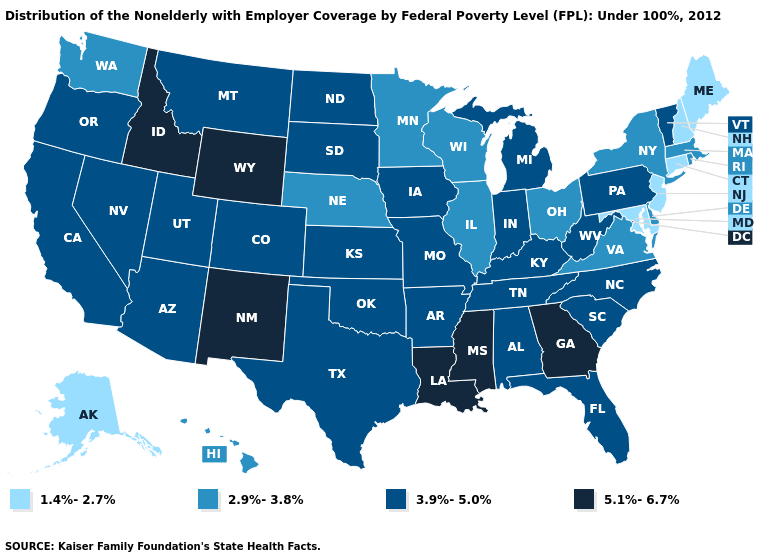What is the value of Kansas?
Concise answer only. 3.9%-5.0%. Does the first symbol in the legend represent the smallest category?
Concise answer only. Yes. Name the states that have a value in the range 3.9%-5.0%?
Be succinct. Alabama, Arizona, Arkansas, California, Colorado, Florida, Indiana, Iowa, Kansas, Kentucky, Michigan, Missouri, Montana, Nevada, North Carolina, North Dakota, Oklahoma, Oregon, Pennsylvania, South Carolina, South Dakota, Tennessee, Texas, Utah, Vermont, West Virginia. What is the value of Georgia?
Give a very brief answer. 5.1%-6.7%. What is the lowest value in the MidWest?
Concise answer only. 2.9%-3.8%. Which states hav the highest value in the West?
Give a very brief answer. Idaho, New Mexico, Wyoming. Does the first symbol in the legend represent the smallest category?
Give a very brief answer. Yes. What is the lowest value in the USA?
Keep it brief. 1.4%-2.7%. Name the states that have a value in the range 5.1%-6.7%?
Write a very short answer. Georgia, Idaho, Louisiana, Mississippi, New Mexico, Wyoming. Name the states that have a value in the range 5.1%-6.7%?
Give a very brief answer. Georgia, Idaho, Louisiana, Mississippi, New Mexico, Wyoming. Does the map have missing data?
Write a very short answer. No. Among the states that border Georgia , which have the highest value?
Give a very brief answer. Alabama, Florida, North Carolina, South Carolina, Tennessee. Name the states that have a value in the range 1.4%-2.7%?
Concise answer only. Alaska, Connecticut, Maine, Maryland, New Hampshire, New Jersey. Does Utah have the highest value in the West?
Concise answer only. No. Name the states that have a value in the range 5.1%-6.7%?
Write a very short answer. Georgia, Idaho, Louisiana, Mississippi, New Mexico, Wyoming. 